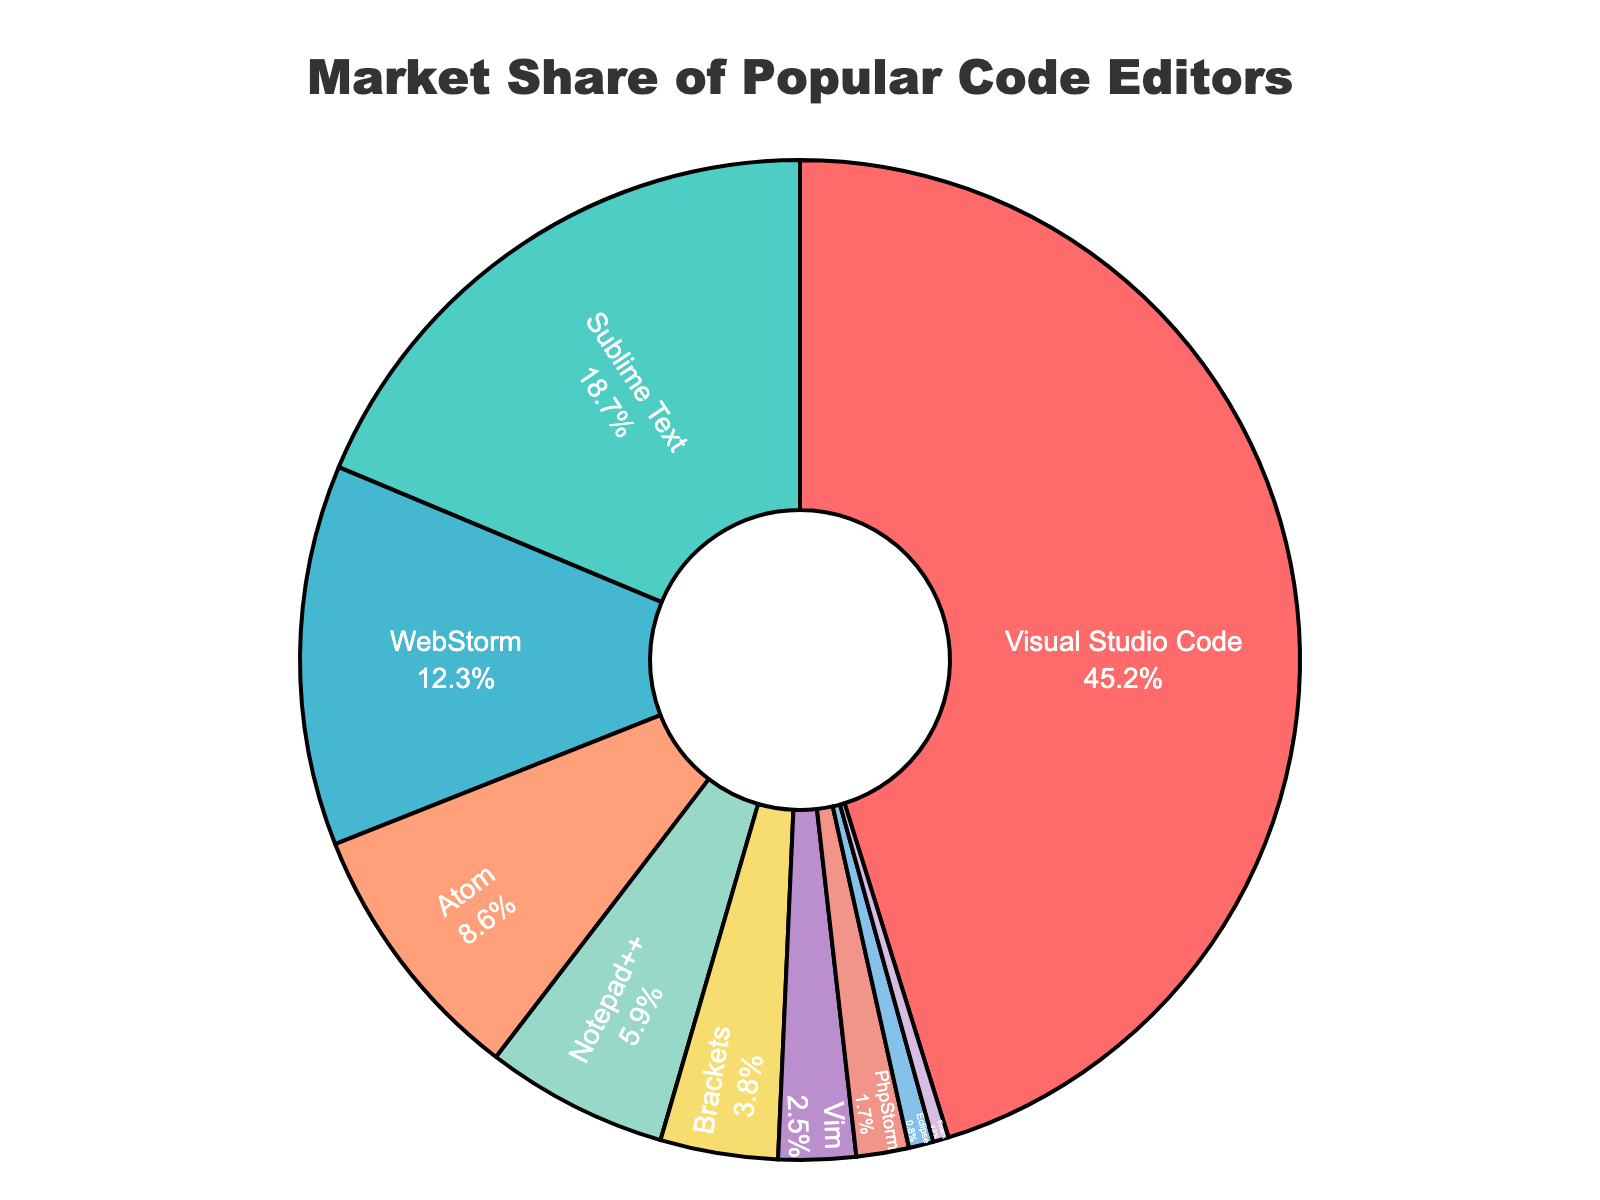What is the market share of Visual Studio Code? Visual Studio Code's market share is indicated on the chart. Since it is the largest segment, its percentage is labeled directly on the pie chart.
Answer: 45.2% How does Sublime Text's market share compare with Atom's market share? Sublime Text's market share is 18.7%, and Atom's market share is 8.6%. By comparing these values, Sublime Text has a larger market share.
Answer: Sublime Text has a larger market share What is the combined market share of WebStorm and Notepad++? WebStorm's market share is 12.3%, and Notepad++'s market share is 5.9%. By adding these percentages together: 12.3 + 5.9 = 18.2%.
Answer: 18.2% Which code editor has the smallest market share, and what is its percentage? According to the pie chart, Emacs is the smallest segment. Its market share is provided on the chart.
Answer: Emacs, 0.5% How much greater is the market share of Visual Studio Code compared to Brackets? Visual Studio Code's market share is 45.2%, and Brackets' market share is 3.8%. The difference is found by subtraction: 45.2 - 3.8 = 41.4%.
Answer: 41.4% Arrange the code editors in ascending order of their market share. To arrange the code editors from the smallest to largest market share: Emacs (0.5%), Eclipse (0.8%), PhpStorm (1.7%), Vim (2.5%), Brackets (3.8%), Notepad++ (5.9%), Atom (8.6%), WebStorm (12.3%), Sublime Text (18.7%), Visual Studio Code (45.2%).
Answer: Emacs, Eclipse, PhpStorm, Vim, Brackets, Notepad++, Atom, WebStorm, Sublime Text, Visual Studio Code Which color is used for Sublime Text in the pie chart? By observing the visual cues and color legend in the pie chart, Sublime Text is associated with a particular color.
Answer: green What portion of the market share do editors other than Visual Studio Code, Sublime Text, and Atom hold together? First, compute the total percentage for Visual Studio Code, Sublime Text, and Atom: 45.2% + 18.7% + 8.6% = 72.5%. The remaining editors' combined market share is: 100% - 72.5% = 27.5%.
Answer: 27.5% What is the average market share of Notepad++, Brackets, and Vim? Adding the market shares for Notepad++ (5.9%), Brackets (3.8%), and Vim (2.5%) and dividing by 3: (5.9 + 3.8 + 2.5) / 3 ≈ 4.07%.
Answer: 4.07% Which code editors have a market share less than 5%? From the pie chart, the code editors with a market share less than 5% are Brackets, Vim, PhpStorm, Eclipse, and Emacs.
Answer: Brackets, Vim, PhpStorm, Eclipse, Emacs 